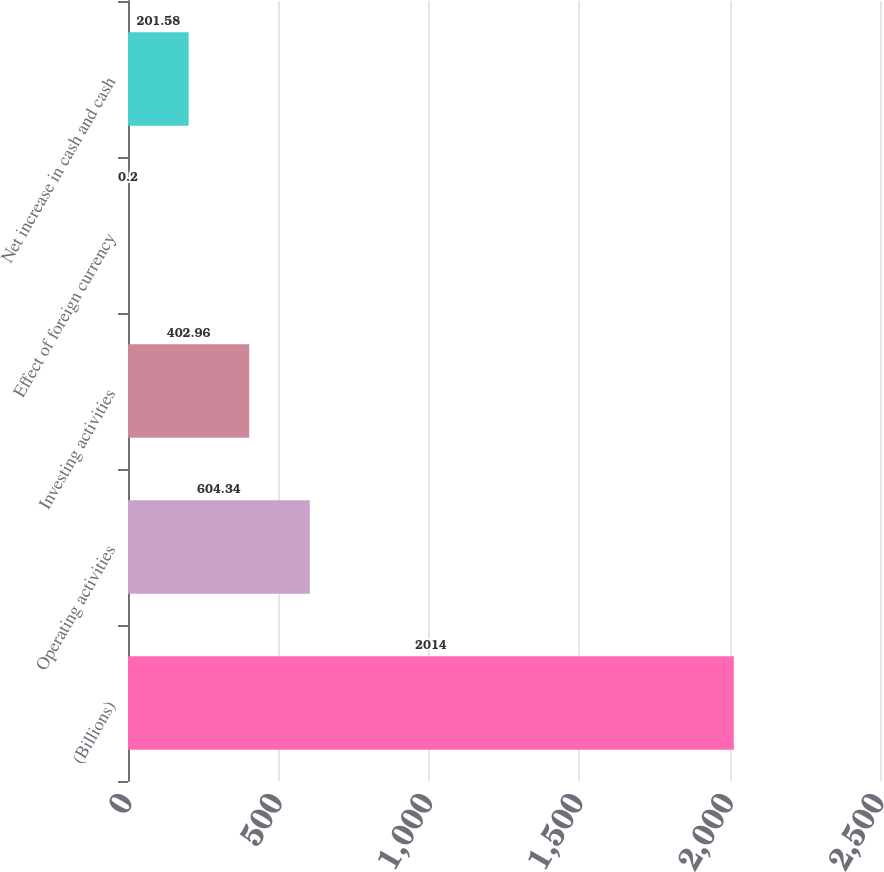Convert chart. <chart><loc_0><loc_0><loc_500><loc_500><bar_chart><fcel>(Billions)<fcel>Operating activities<fcel>Investing activities<fcel>Effect of foreign currency<fcel>Net increase in cash and cash<nl><fcel>2014<fcel>604.34<fcel>402.96<fcel>0.2<fcel>201.58<nl></chart> 